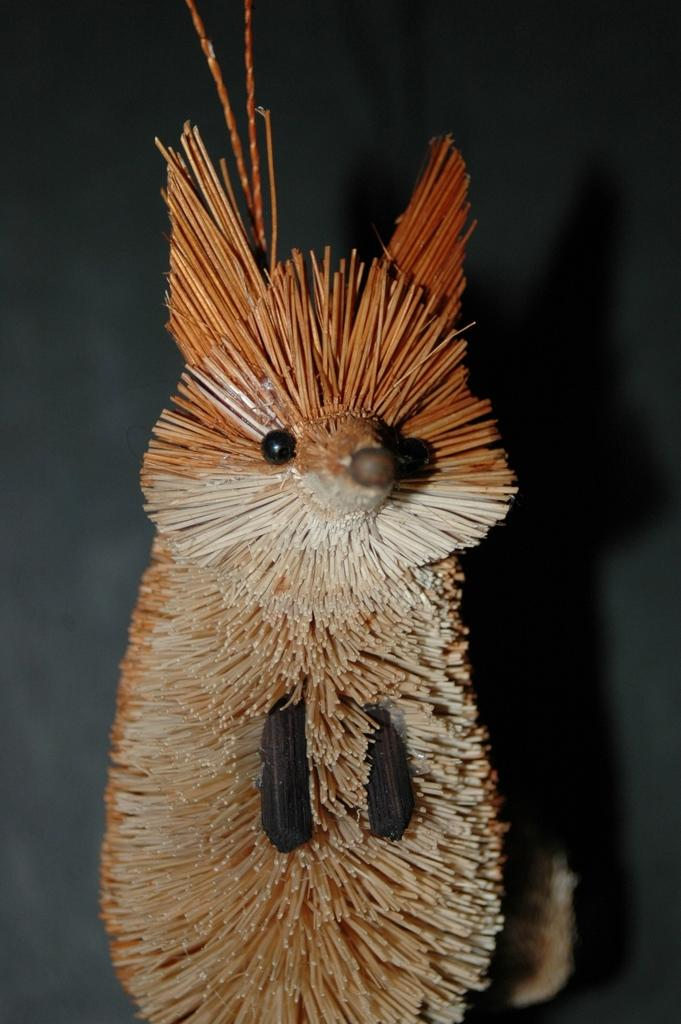What type of toy can be seen in the image? There is a toy made with stick-like objects in the image. What can be observed about the background of the image? The background of the image is dark. How does the pencil compare to the toy in the image? There is no pencil present in the image, so it cannot be compared to the toy. 